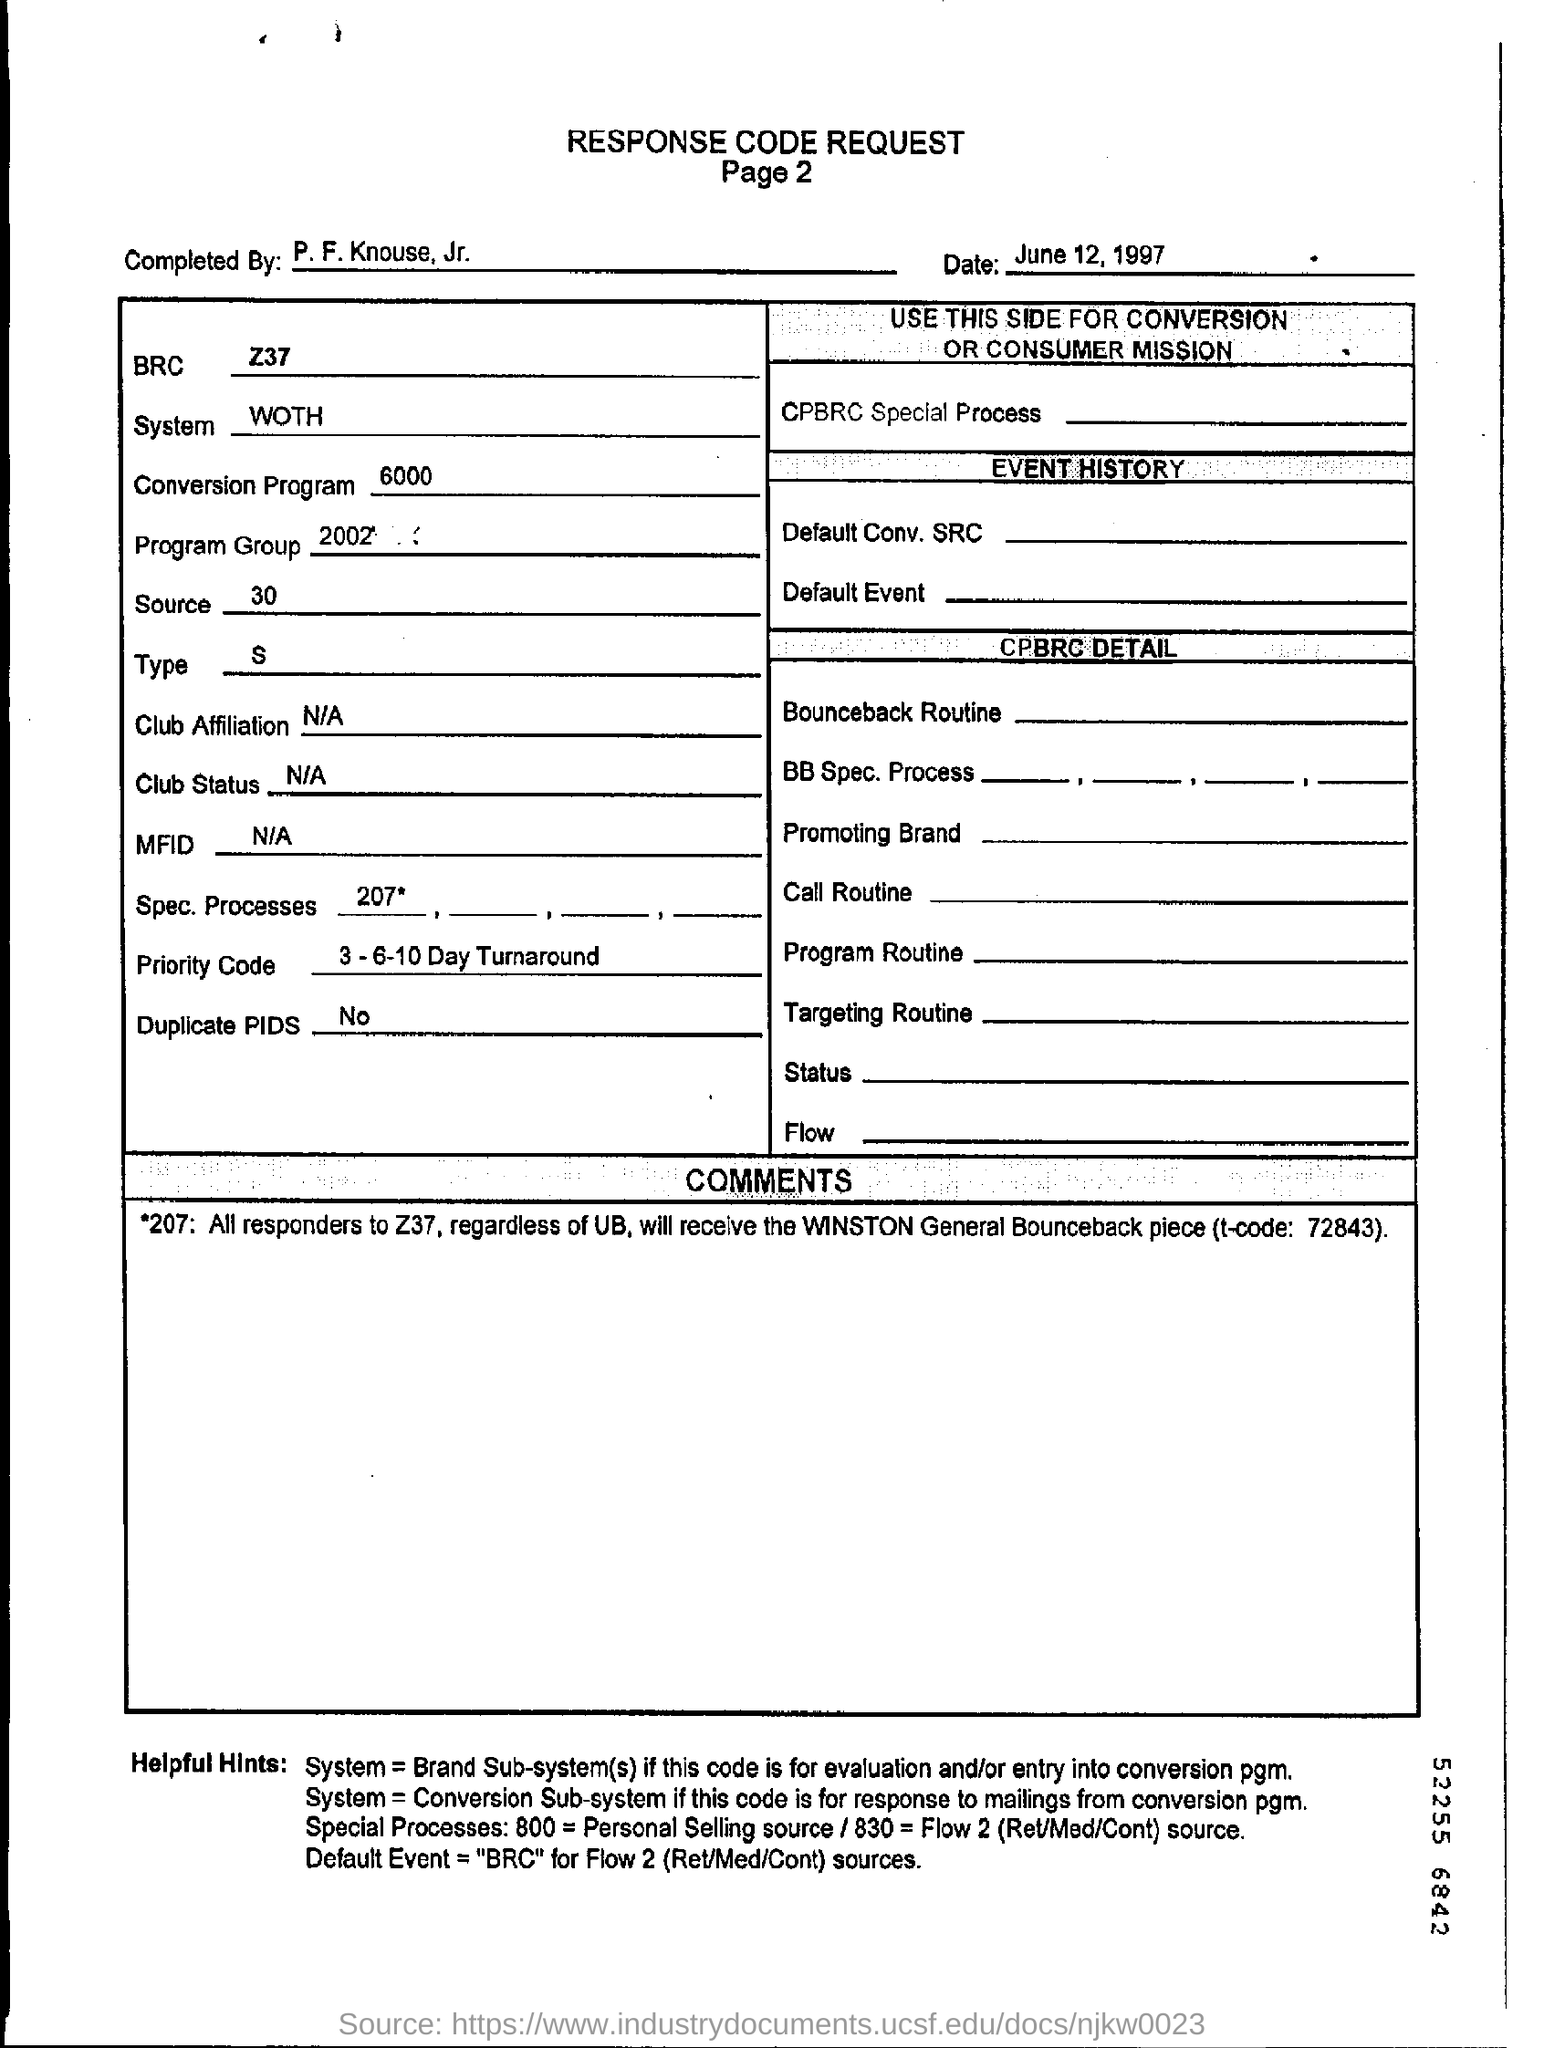What is the system mentioned in the form?
Give a very brief answer. WOTH. 